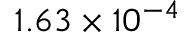Convert formula to latex. <formula><loc_0><loc_0><loc_500><loc_500>1 . 6 3 \times 1 0 ^ { - 4 }</formula> 